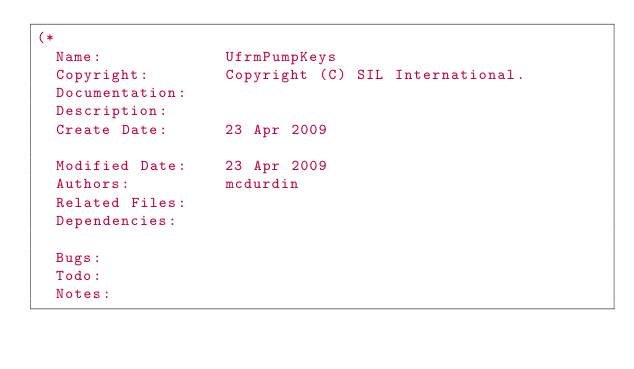Convert code to text. <code><loc_0><loc_0><loc_500><loc_500><_Pascal_>(*
  Name:             UfrmPumpKeys
  Copyright:        Copyright (C) SIL International.
  Documentation:    
  Description:      
  Create Date:      23 Apr 2009

  Modified Date:    23 Apr 2009
  Authors:          mcdurdin
  Related Files:    
  Dependencies:     

  Bugs:             
  Todo:             
  Notes:            </code> 